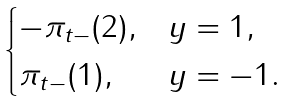Convert formula to latex. <formula><loc_0><loc_0><loc_500><loc_500>\begin{cases} - \pi _ { t - } ( 2 ) , & y = 1 , \\ \pi _ { t - } ( 1 ) , & y = - 1 . \end{cases}</formula> 